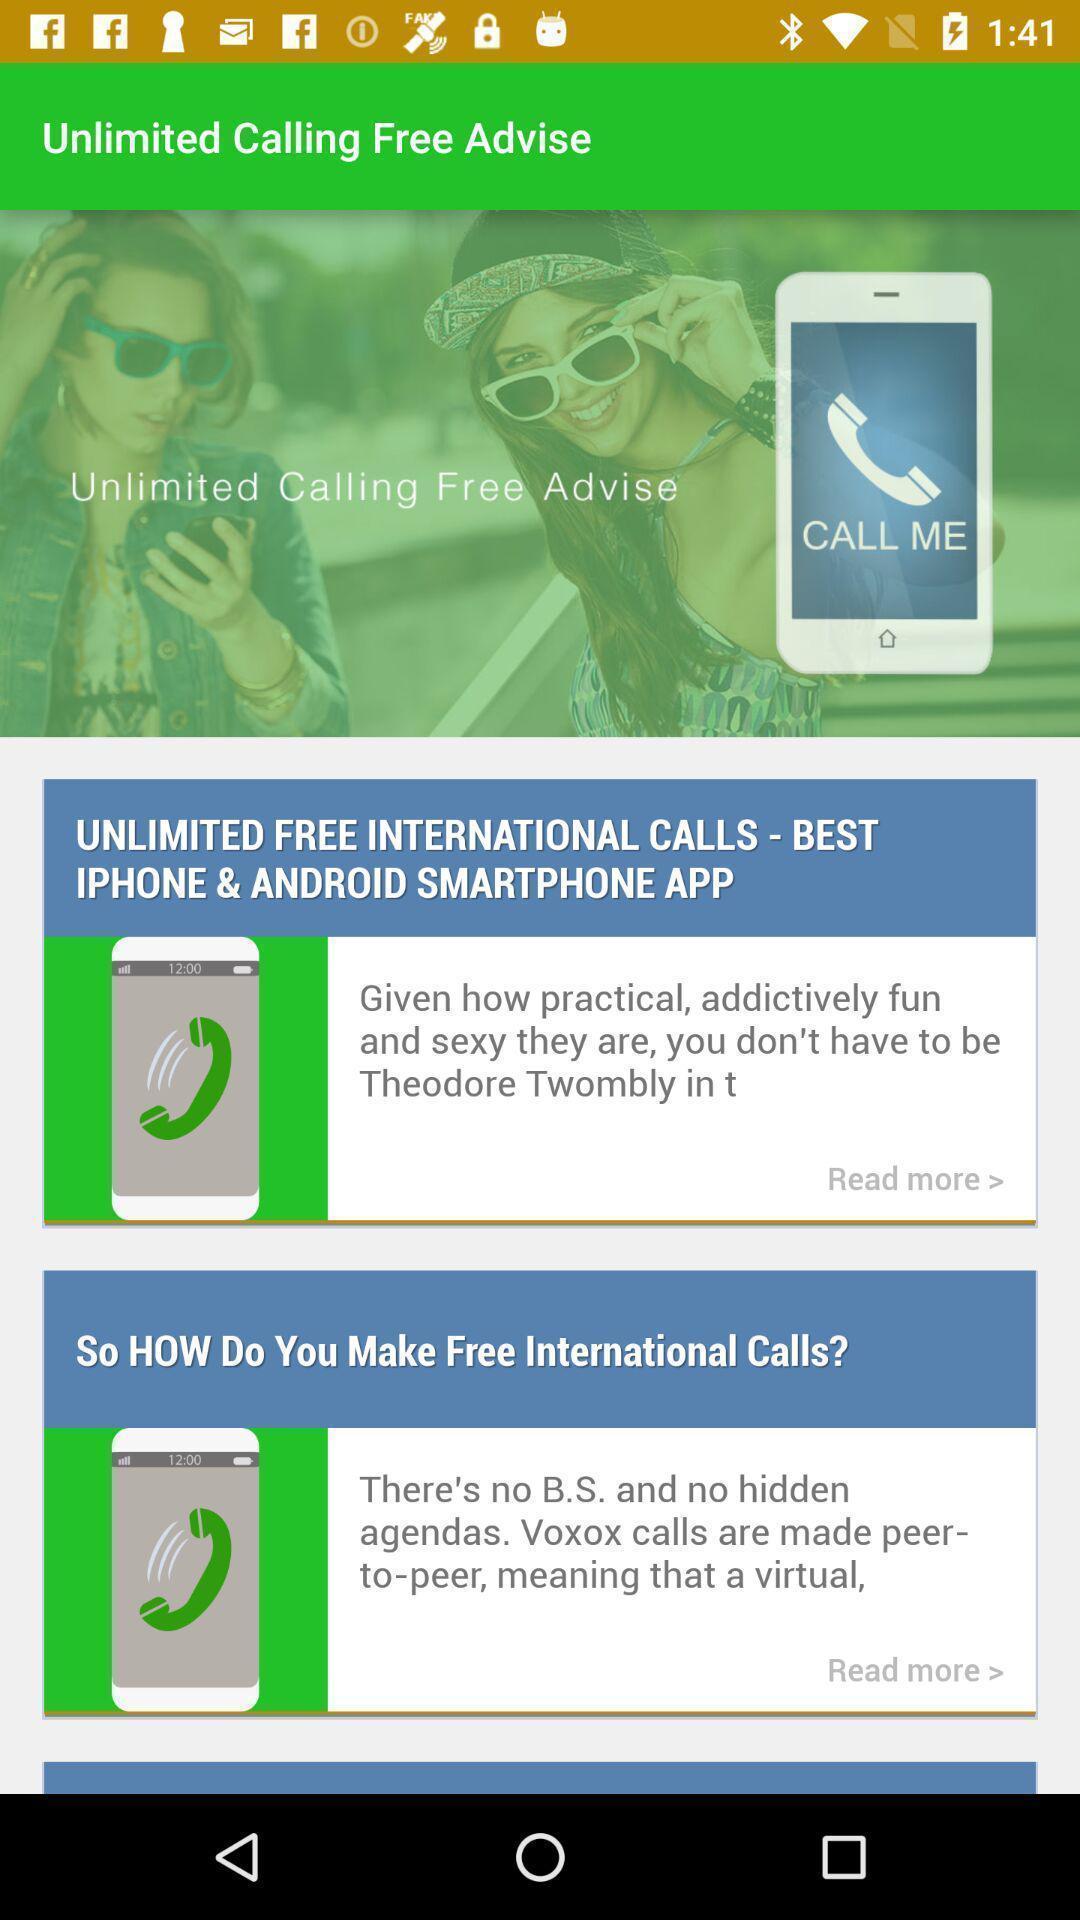What is the overall content of this screenshot? Screen shows information about caller app. 